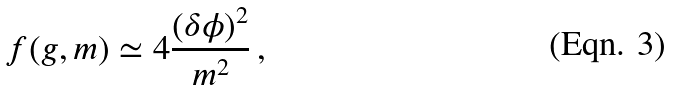Convert formula to latex. <formula><loc_0><loc_0><loc_500><loc_500>f ( g , m ) \simeq 4 \frac { ( \delta \phi ) ^ { 2 } } { m ^ { 2 } } \, ,</formula> 